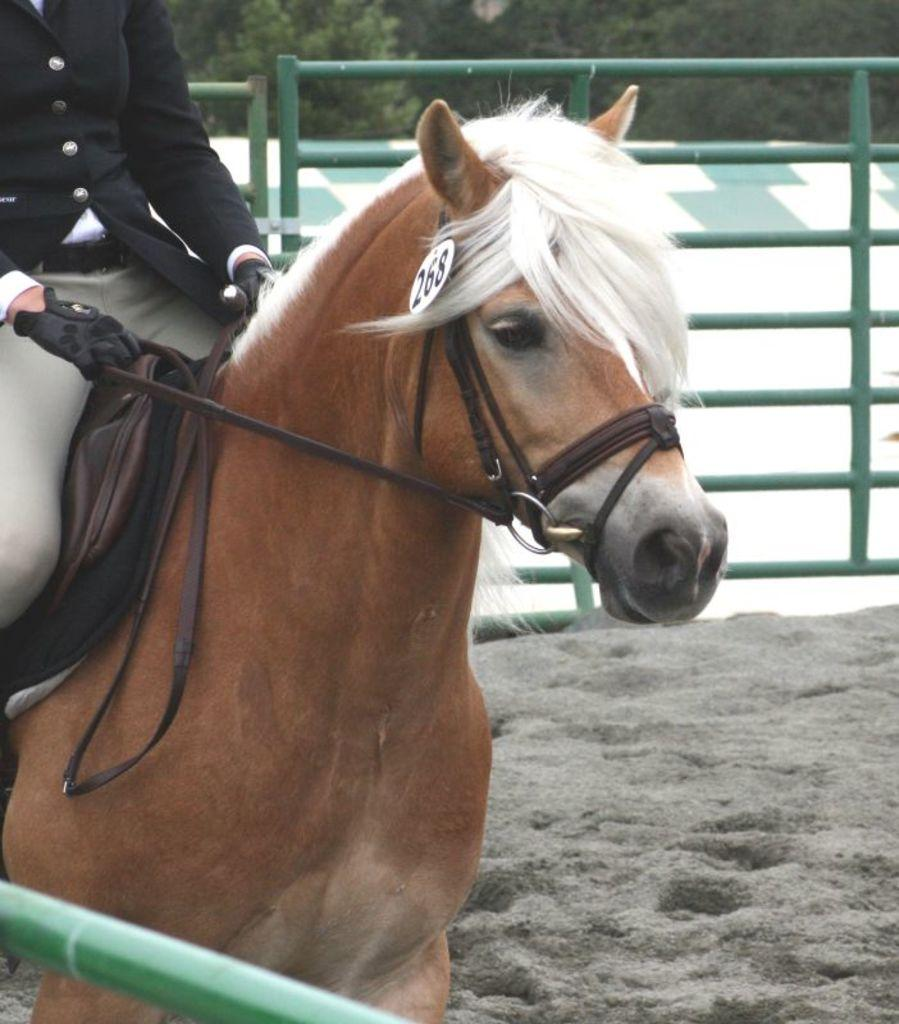What is the person in the image doing? There is a person standing on a horse in the image. What can be seen in the middle of the image? There is a tree in the middle of the image. What type of humor can be found in the title of the image? There is no title present in the image, so it is not possible to determine what type of humor might be found in it. 